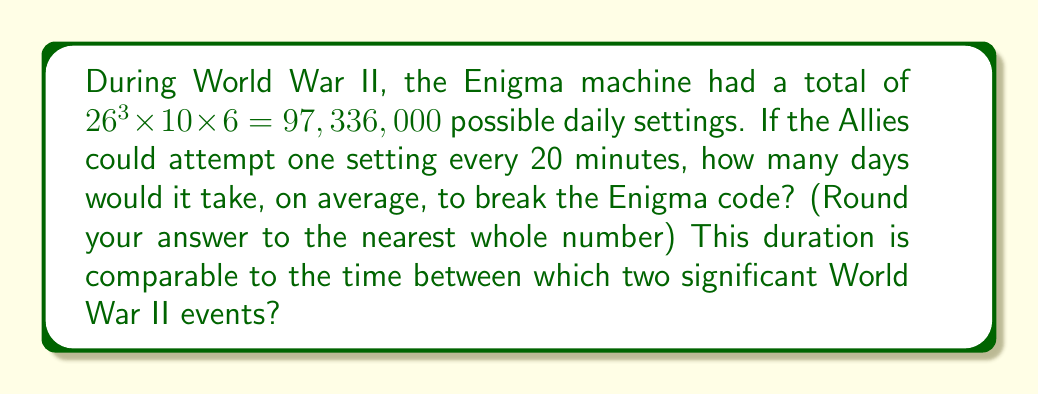Could you help me with this problem? Let's approach this step-by-step:

1) First, we need to calculate how many settings can be attempted per day:
   $$ \text{Settings per day} = \frac{24 \text{ hours} \times 60 \text{ minutes/hour}}{20 \text{ minutes/setting}} = 72 \text{ settings/day} $$

2) Now, we need to find the average number of attempts needed to break the code. In probability theory, for a uniform distribution, the average number of attempts is half of the total possibilities:
   $$ \text{Average attempts} = \frac{97,336,000}{2} = 48,668,000 $$

3) To find the number of days, we divide the average attempts by the settings per day:
   $$ \text{Days} = \frac{48,668,000}{72} \approx 675,944.44 \text{ days} $$

4) Rounding to the nearest whole number:
   $$ \text{Days} \approx 675,944 \text{ days} $$

5) This is equivalent to about 1,851 years.

Historically, this duration is comparable to the time between the fall of the Western Roman Empire (476 AD) and the start of World War II (1939 AD), which is about 1,463 years. This comparison illustrates the astronomical difficulty of breaking the Enigma code by brute force, highlighting the importance of the codebreakers' innovative methods and captured Enigma machines in the actual breaking of the code.
Answer: 675,944 days 